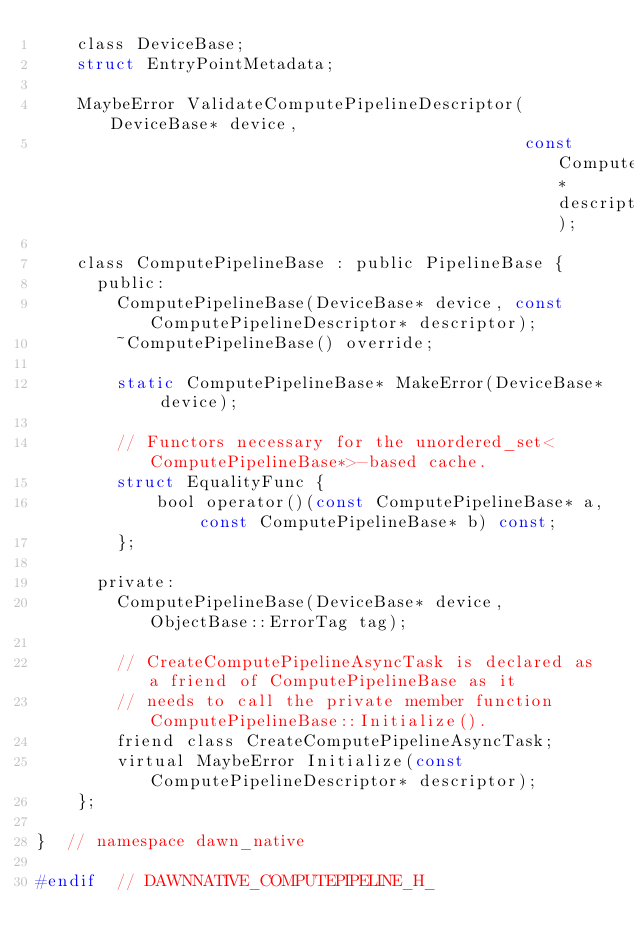<code> <loc_0><loc_0><loc_500><loc_500><_C_>    class DeviceBase;
    struct EntryPointMetadata;

    MaybeError ValidateComputePipelineDescriptor(DeviceBase* device,
                                                 const ComputePipelineDescriptor* descriptor);

    class ComputePipelineBase : public PipelineBase {
      public:
        ComputePipelineBase(DeviceBase* device, const ComputePipelineDescriptor* descriptor);
        ~ComputePipelineBase() override;

        static ComputePipelineBase* MakeError(DeviceBase* device);

        // Functors necessary for the unordered_set<ComputePipelineBase*>-based cache.
        struct EqualityFunc {
            bool operator()(const ComputePipelineBase* a, const ComputePipelineBase* b) const;
        };

      private:
        ComputePipelineBase(DeviceBase* device, ObjectBase::ErrorTag tag);

        // CreateComputePipelineAsyncTask is declared as a friend of ComputePipelineBase as it
        // needs to call the private member function ComputePipelineBase::Initialize().
        friend class CreateComputePipelineAsyncTask;
        virtual MaybeError Initialize(const ComputePipelineDescriptor* descriptor);
    };

}  // namespace dawn_native

#endif  // DAWNNATIVE_COMPUTEPIPELINE_H_
</code> 